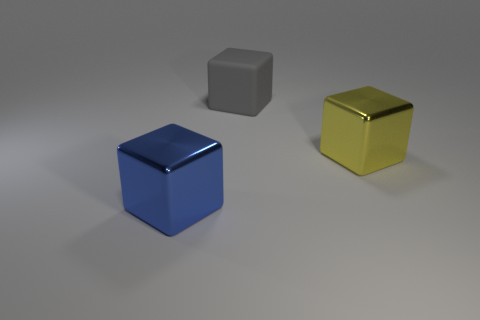Add 3 large cyan metal blocks. How many objects exist? 6 Add 1 large blue metallic objects. How many large blue metallic objects exist? 2 Subtract 0 blue balls. How many objects are left? 3 Subtract all rubber objects. Subtract all large gray objects. How many objects are left? 1 Add 3 yellow things. How many yellow things are left? 4 